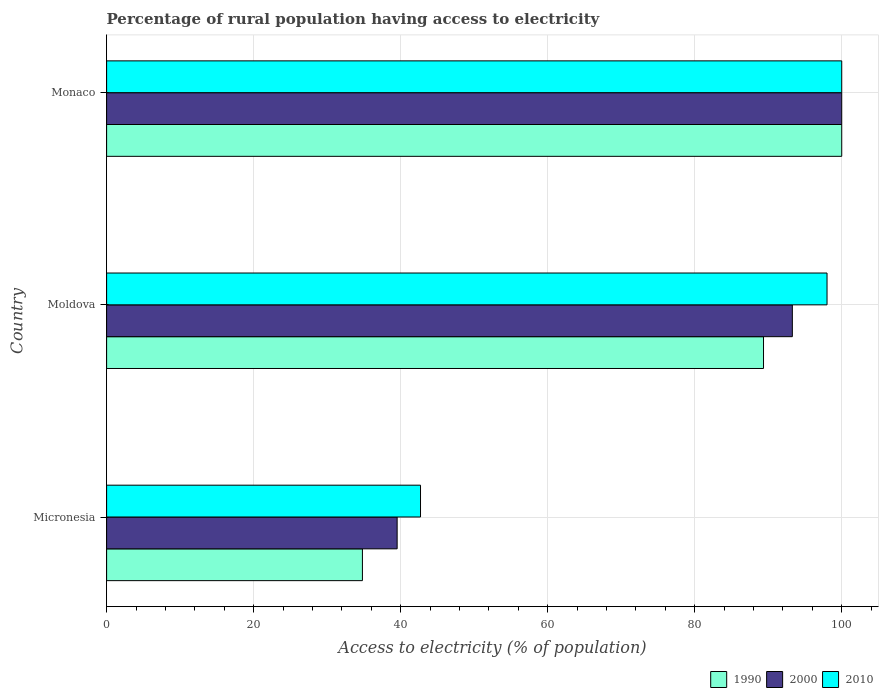How many groups of bars are there?
Keep it short and to the point. 3. How many bars are there on the 2nd tick from the top?
Provide a succinct answer. 3. What is the label of the 2nd group of bars from the top?
Keep it short and to the point. Moldova. In how many cases, is the number of bars for a given country not equal to the number of legend labels?
Your answer should be very brief. 0. Across all countries, what is the maximum percentage of rural population having access to electricity in 2000?
Your response must be concise. 100. Across all countries, what is the minimum percentage of rural population having access to electricity in 2010?
Your response must be concise. 42.7. In which country was the percentage of rural population having access to electricity in 1990 maximum?
Your answer should be very brief. Monaco. In which country was the percentage of rural population having access to electricity in 1990 minimum?
Keep it short and to the point. Micronesia. What is the total percentage of rural population having access to electricity in 2000 in the graph?
Provide a short and direct response. 232.8. What is the difference between the percentage of rural population having access to electricity in 1990 in Micronesia and that in Monaco?
Offer a terse response. -65.2. What is the difference between the percentage of rural population having access to electricity in 1990 in Monaco and the percentage of rural population having access to electricity in 2010 in Micronesia?
Offer a terse response. 57.3. What is the average percentage of rural population having access to electricity in 2010 per country?
Offer a terse response. 80.23. In how many countries, is the percentage of rural population having access to electricity in 1990 greater than 72 %?
Your answer should be very brief. 2. What is the ratio of the percentage of rural population having access to electricity in 2010 in Micronesia to that in Monaco?
Provide a short and direct response. 0.43. Is the percentage of rural population having access to electricity in 2000 in Moldova less than that in Monaco?
Provide a succinct answer. Yes. What is the difference between the highest and the second highest percentage of rural population having access to electricity in 1990?
Give a very brief answer. 10.64. What is the difference between the highest and the lowest percentage of rural population having access to electricity in 1990?
Your response must be concise. 65.2. In how many countries, is the percentage of rural population having access to electricity in 1990 greater than the average percentage of rural population having access to electricity in 1990 taken over all countries?
Give a very brief answer. 2. What does the 2nd bar from the top in Moldova represents?
Your answer should be compact. 2000. What does the 2nd bar from the bottom in Monaco represents?
Offer a terse response. 2000. Is it the case that in every country, the sum of the percentage of rural population having access to electricity in 1990 and percentage of rural population having access to electricity in 2010 is greater than the percentage of rural population having access to electricity in 2000?
Ensure brevity in your answer.  Yes. Are all the bars in the graph horizontal?
Provide a succinct answer. Yes. What is the difference between two consecutive major ticks on the X-axis?
Make the answer very short. 20. Are the values on the major ticks of X-axis written in scientific E-notation?
Keep it short and to the point. No. Where does the legend appear in the graph?
Provide a succinct answer. Bottom right. How are the legend labels stacked?
Offer a terse response. Horizontal. What is the title of the graph?
Provide a short and direct response. Percentage of rural population having access to electricity. Does "1999" appear as one of the legend labels in the graph?
Your answer should be compact. No. What is the label or title of the X-axis?
Offer a very short reply. Access to electricity (% of population). What is the Access to electricity (% of population) of 1990 in Micronesia?
Your answer should be very brief. 34.8. What is the Access to electricity (% of population) in 2000 in Micronesia?
Keep it short and to the point. 39.52. What is the Access to electricity (% of population) in 2010 in Micronesia?
Provide a succinct answer. 42.7. What is the Access to electricity (% of population) of 1990 in Moldova?
Your response must be concise. 89.36. What is the Access to electricity (% of population) in 2000 in Moldova?
Make the answer very short. 93.28. What is the Access to electricity (% of population) of 2010 in Moldova?
Offer a terse response. 98. What is the Access to electricity (% of population) in 1990 in Monaco?
Keep it short and to the point. 100. What is the Access to electricity (% of population) of 2000 in Monaco?
Make the answer very short. 100. What is the Access to electricity (% of population) of 2010 in Monaco?
Ensure brevity in your answer.  100. Across all countries, what is the maximum Access to electricity (% of population) of 2000?
Provide a succinct answer. 100. Across all countries, what is the minimum Access to electricity (% of population) of 1990?
Provide a short and direct response. 34.8. Across all countries, what is the minimum Access to electricity (% of population) in 2000?
Ensure brevity in your answer.  39.52. Across all countries, what is the minimum Access to electricity (% of population) of 2010?
Provide a short and direct response. 42.7. What is the total Access to electricity (% of population) in 1990 in the graph?
Ensure brevity in your answer.  224.16. What is the total Access to electricity (% of population) in 2000 in the graph?
Provide a succinct answer. 232.8. What is the total Access to electricity (% of population) in 2010 in the graph?
Ensure brevity in your answer.  240.7. What is the difference between the Access to electricity (% of population) of 1990 in Micronesia and that in Moldova?
Your answer should be compact. -54.56. What is the difference between the Access to electricity (% of population) of 2000 in Micronesia and that in Moldova?
Your answer should be very brief. -53.76. What is the difference between the Access to electricity (% of population) of 2010 in Micronesia and that in Moldova?
Offer a terse response. -55.3. What is the difference between the Access to electricity (% of population) of 1990 in Micronesia and that in Monaco?
Provide a succinct answer. -65.2. What is the difference between the Access to electricity (% of population) of 2000 in Micronesia and that in Monaco?
Your response must be concise. -60.48. What is the difference between the Access to electricity (% of population) of 2010 in Micronesia and that in Monaco?
Make the answer very short. -57.3. What is the difference between the Access to electricity (% of population) of 1990 in Moldova and that in Monaco?
Provide a short and direct response. -10.64. What is the difference between the Access to electricity (% of population) of 2000 in Moldova and that in Monaco?
Offer a terse response. -6.72. What is the difference between the Access to electricity (% of population) of 2010 in Moldova and that in Monaco?
Your response must be concise. -2. What is the difference between the Access to electricity (% of population) of 1990 in Micronesia and the Access to electricity (% of population) of 2000 in Moldova?
Provide a succinct answer. -58.48. What is the difference between the Access to electricity (% of population) in 1990 in Micronesia and the Access to electricity (% of population) in 2010 in Moldova?
Provide a succinct answer. -63.2. What is the difference between the Access to electricity (% of population) in 2000 in Micronesia and the Access to electricity (% of population) in 2010 in Moldova?
Offer a terse response. -58.48. What is the difference between the Access to electricity (% of population) of 1990 in Micronesia and the Access to electricity (% of population) of 2000 in Monaco?
Your answer should be very brief. -65.2. What is the difference between the Access to electricity (% of population) of 1990 in Micronesia and the Access to electricity (% of population) of 2010 in Monaco?
Your answer should be very brief. -65.2. What is the difference between the Access to electricity (% of population) in 2000 in Micronesia and the Access to electricity (% of population) in 2010 in Monaco?
Offer a terse response. -60.48. What is the difference between the Access to electricity (% of population) of 1990 in Moldova and the Access to electricity (% of population) of 2000 in Monaco?
Provide a short and direct response. -10.64. What is the difference between the Access to electricity (% of population) in 1990 in Moldova and the Access to electricity (% of population) in 2010 in Monaco?
Provide a succinct answer. -10.64. What is the difference between the Access to electricity (% of population) in 2000 in Moldova and the Access to electricity (% of population) in 2010 in Monaco?
Provide a short and direct response. -6.72. What is the average Access to electricity (% of population) of 1990 per country?
Your answer should be compact. 74.72. What is the average Access to electricity (% of population) of 2000 per country?
Offer a very short reply. 77.6. What is the average Access to electricity (% of population) of 2010 per country?
Keep it short and to the point. 80.23. What is the difference between the Access to electricity (% of population) in 1990 and Access to electricity (% of population) in 2000 in Micronesia?
Offer a very short reply. -4.72. What is the difference between the Access to electricity (% of population) in 1990 and Access to electricity (% of population) in 2010 in Micronesia?
Give a very brief answer. -7.9. What is the difference between the Access to electricity (% of population) in 2000 and Access to electricity (% of population) in 2010 in Micronesia?
Give a very brief answer. -3.18. What is the difference between the Access to electricity (% of population) in 1990 and Access to electricity (% of population) in 2000 in Moldova?
Your response must be concise. -3.92. What is the difference between the Access to electricity (% of population) in 1990 and Access to electricity (% of population) in 2010 in Moldova?
Provide a short and direct response. -8.64. What is the difference between the Access to electricity (% of population) of 2000 and Access to electricity (% of population) of 2010 in Moldova?
Provide a succinct answer. -4.72. What is the difference between the Access to electricity (% of population) of 1990 and Access to electricity (% of population) of 2010 in Monaco?
Ensure brevity in your answer.  0. What is the ratio of the Access to electricity (% of population) in 1990 in Micronesia to that in Moldova?
Offer a very short reply. 0.39. What is the ratio of the Access to electricity (% of population) of 2000 in Micronesia to that in Moldova?
Provide a short and direct response. 0.42. What is the ratio of the Access to electricity (% of population) of 2010 in Micronesia to that in Moldova?
Provide a succinct answer. 0.44. What is the ratio of the Access to electricity (% of population) in 1990 in Micronesia to that in Monaco?
Provide a succinct answer. 0.35. What is the ratio of the Access to electricity (% of population) of 2000 in Micronesia to that in Monaco?
Provide a short and direct response. 0.4. What is the ratio of the Access to electricity (% of population) in 2010 in Micronesia to that in Monaco?
Provide a succinct answer. 0.43. What is the ratio of the Access to electricity (% of population) of 1990 in Moldova to that in Monaco?
Make the answer very short. 0.89. What is the ratio of the Access to electricity (% of population) of 2000 in Moldova to that in Monaco?
Your answer should be very brief. 0.93. What is the difference between the highest and the second highest Access to electricity (% of population) of 1990?
Your response must be concise. 10.64. What is the difference between the highest and the second highest Access to electricity (% of population) in 2000?
Ensure brevity in your answer.  6.72. What is the difference between the highest and the lowest Access to electricity (% of population) of 1990?
Ensure brevity in your answer.  65.2. What is the difference between the highest and the lowest Access to electricity (% of population) in 2000?
Your response must be concise. 60.48. What is the difference between the highest and the lowest Access to electricity (% of population) in 2010?
Give a very brief answer. 57.3. 